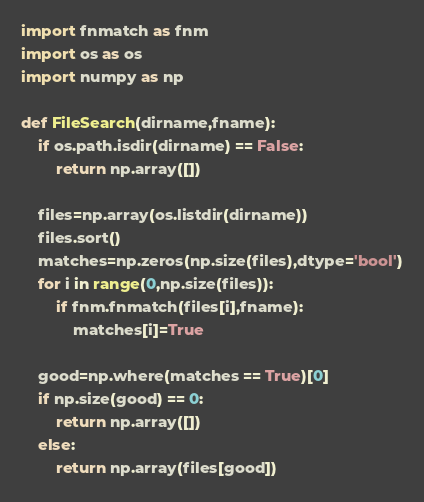<code> <loc_0><loc_0><loc_500><loc_500><_Python_>import fnmatch as fnm
import os as os
import numpy as np

def FileSearch(dirname,fname):
	if os.path.isdir(dirname) == False:
		return np.array([])
		
	files=np.array(os.listdir(dirname))
	files.sort()
	matches=np.zeros(np.size(files),dtype='bool')
	for i in range(0,np.size(files)):
		if fnm.fnmatch(files[i],fname):
			matches[i]=True
	
	good=np.where(matches == True)[0]
	if np.size(good) == 0:
		return np.array([])
	else:
		return np.array(files[good])
</code> 